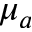<formula> <loc_0><loc_0><loc_500><loc_500>\mu _ { a }</formula> 